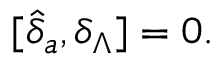Convert formula to latex. <formula><loc_0><loc_0><loc_500><loc_500>[ \widehat { \delta } _ { a } , \delta _ { \Lambda } ] = 0 .</formula> 